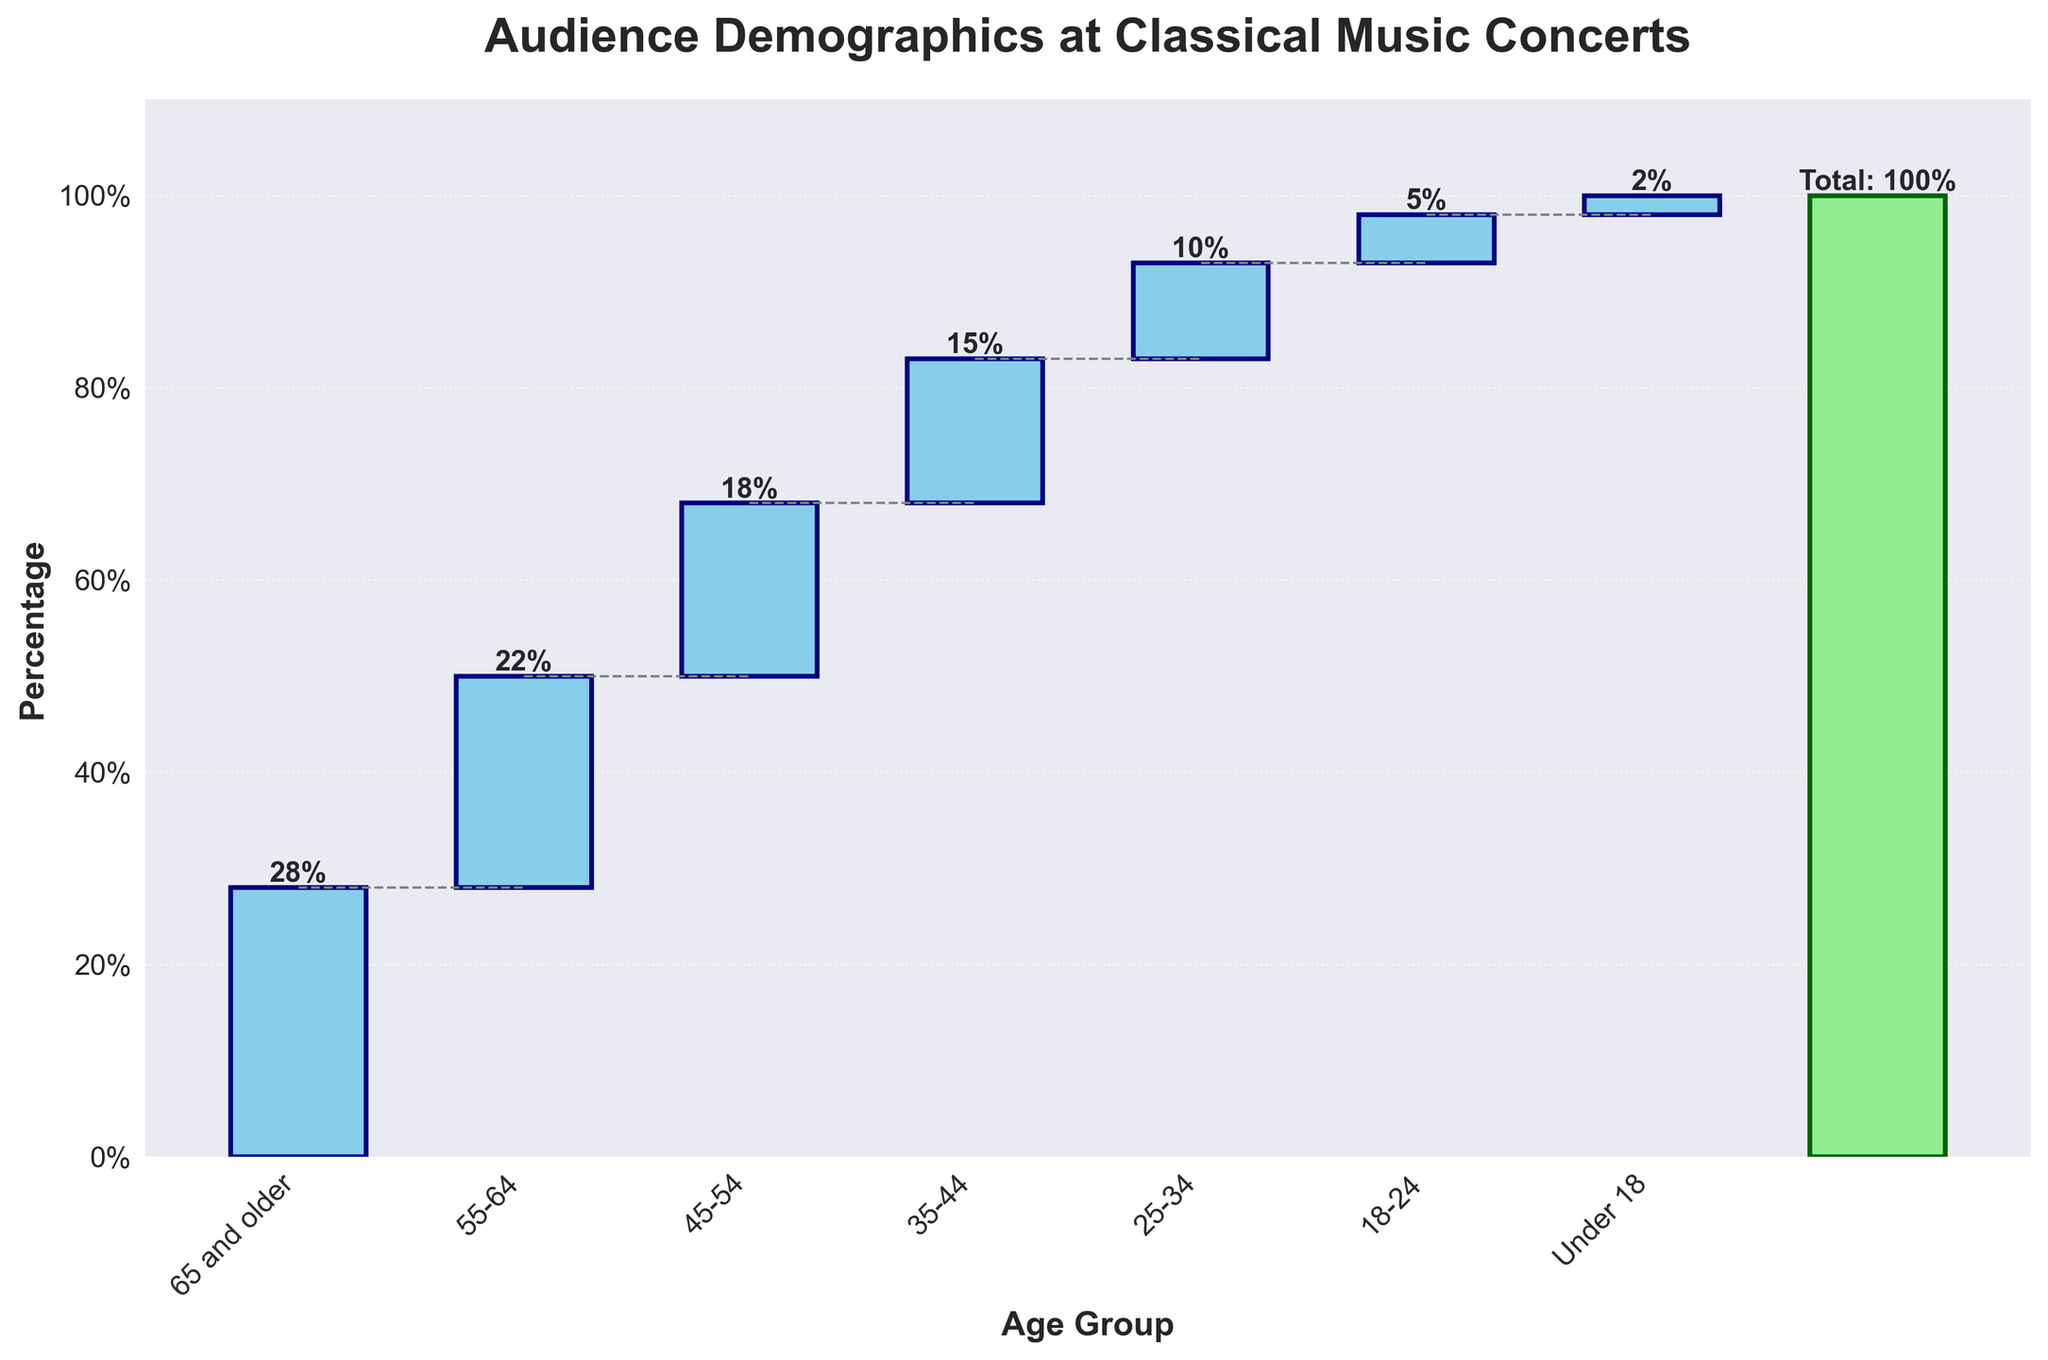What is the percentage of the total audience that is under 18 years old? We look at the age group "Under 18" in the figure and observe the value next to it. The chart shows "2%" as the percentage for this age group.
Answer: 2% Which age group has the highest percentage of attendees? We look at the waterfall chart and identify the highest bar. The age group "65 and older" has the tallest bar, indicating the highest percentage, which is marked as "28%".
Answer: 65 and older What percentage of the audience is between 55 and 64 years old? We refer to the age group "55-64" and observe the percentage value displayed next to its bar, which is "22%".
Answer: 22% What is the combined percentage of the audience for the age groups 35-44, 25-34, and 18-24? To find the combined percentage, we add the values for the age groups "35-44" (15%), "25-34" (10%), and "18-24" (5%). Thus, 15% + 10% + 5% = 30%.
Answer: 30% Which age group has the smallest representation? By examining the shortest bar in the chart, we identify the age group "Under 18" with a 2% representation.
Answer: Under 18 How does the percentage of the 25-34 age group compare to that of the 45-54 age group? Comparing the bars, we see that the "25-34" age group has 10%, while the "45-54" age group has 18%. The "45-54" age group has a higher percentage.
Answer: 45-54 has a higher percentage What is the sum of the percentage values for age groups under 35 years old? We add the percentages from the age groups "Under 18" (2%), "18-24" (5%), and "25-34" (10%). Thus, 2% + 5% + 10% = 17%.
Answer: 17% By how much does the percentage of people aged 65 and older exceed that of people aged 55-64? The percentage for "65 and older" is 28% and for "55-64" is 22%. The difference is 28% - 22% = 6%.
Answer: 6% What percentage of attendees are 45 years old or older? We add the percentages for "45-54" (18%), "55-64" (22%), and "65 and older" (28%). Thus, 18% + 22% + 28% = 68%.
Answer: 68% What patterns of age distribution can you observe from the waterfall chart? Observing the chart, we see that the percentage generally increases with age, peaking in the "65 and older" category, suggesting that older audiences are more likely to attend classical music concerts.
Answer: Older audiences have a higher attendance 